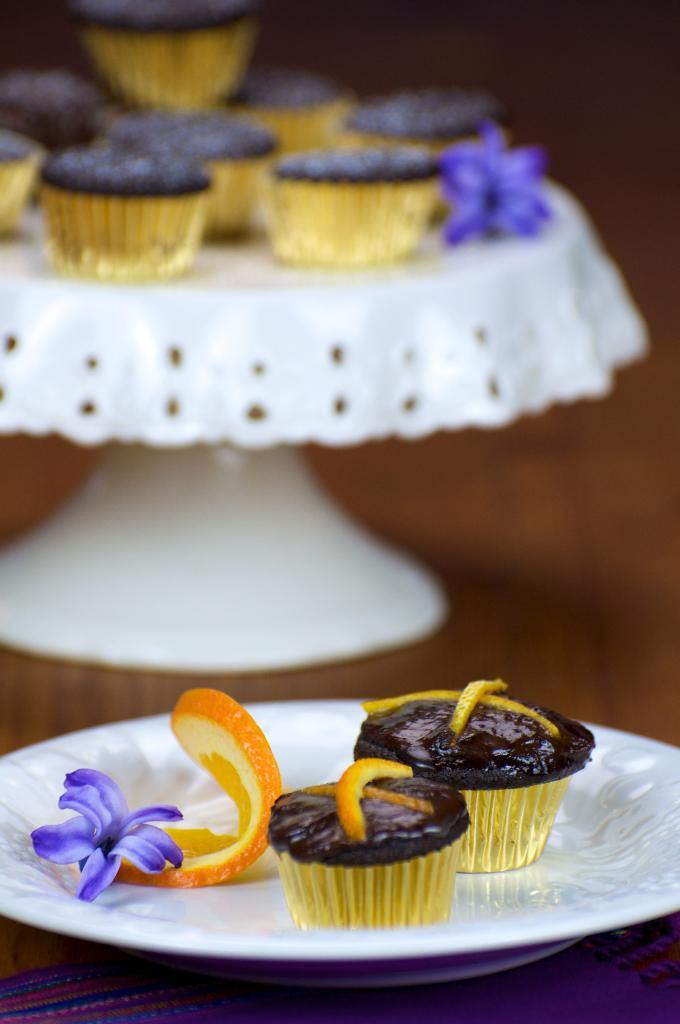What type of food is visible in the image? There are muffins in the image. What decorative element is present on the cake stand? There is a flower on the cake stand. What is the cake stand used for in the image? The cake stand is used to hold the muffins and other items. What other items are present in the plate? There is a flower and an orange slice in the plate. Where is the plate located in the image? The plate is on a table. How many worms are crawling on the muffins in the image? There are no worms present in the image; only muffins, a flower, and an orange slice are visible in the plate. 